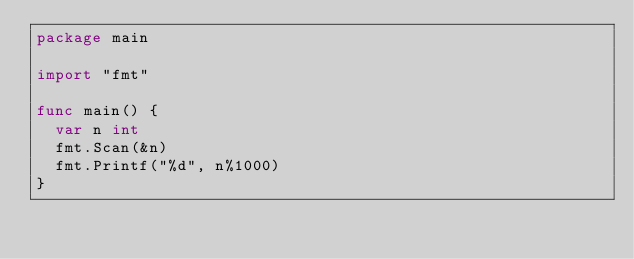<code> <loc_0><loc_0><loc_500><loc_500><_Go_>package main

import "fmt"

func main() {
	var n int
	fmt.Scan(&n)
	fmt.Printf("%d", n%1000)
}
</code> 